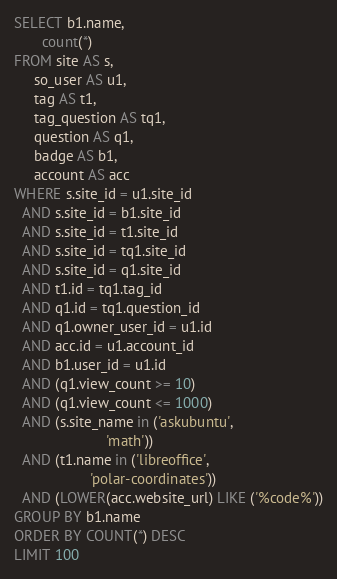<code> <loc_0><loc_0><loc_500><loc_500><_SQL_>SELECT b1.name,
       count(*)
FROM site AS s,
     so_user AS u1,
     tag AS t1,
     tag_question AS tq1,
     question AS q1,
     badge AS b1,
     account AS acc
WHERE s.site_id = u1.site_id
  AND s.site_id = b1.site_id
  AND s.site_id = t1.site_id
  AND s.site_id = tq1.site_id
  AND s.site_id = q1.site_id
  AND t1.id = tq1.tag_id
  AND q1.id = tq1.question_id
  AND q1.owner_user_id = u1.id
  AND acc.id = u1.account_id
  AND b1.user_id = u1.id
  AND (q1.view_count >= 10)
  AND (q1.view_count <= 1000)
  AND (s.site_name in ('askubuntu',
                       'math'))
  AND (t1.name in ('libreoffice',
                   'polar-coordinates'))
  AND (LOWER(acc.website_url) LIKE ('%code%'))
GROUP BY b1.name
ORDER BY COUNT(*) DESC
LIMIT 100</code> 